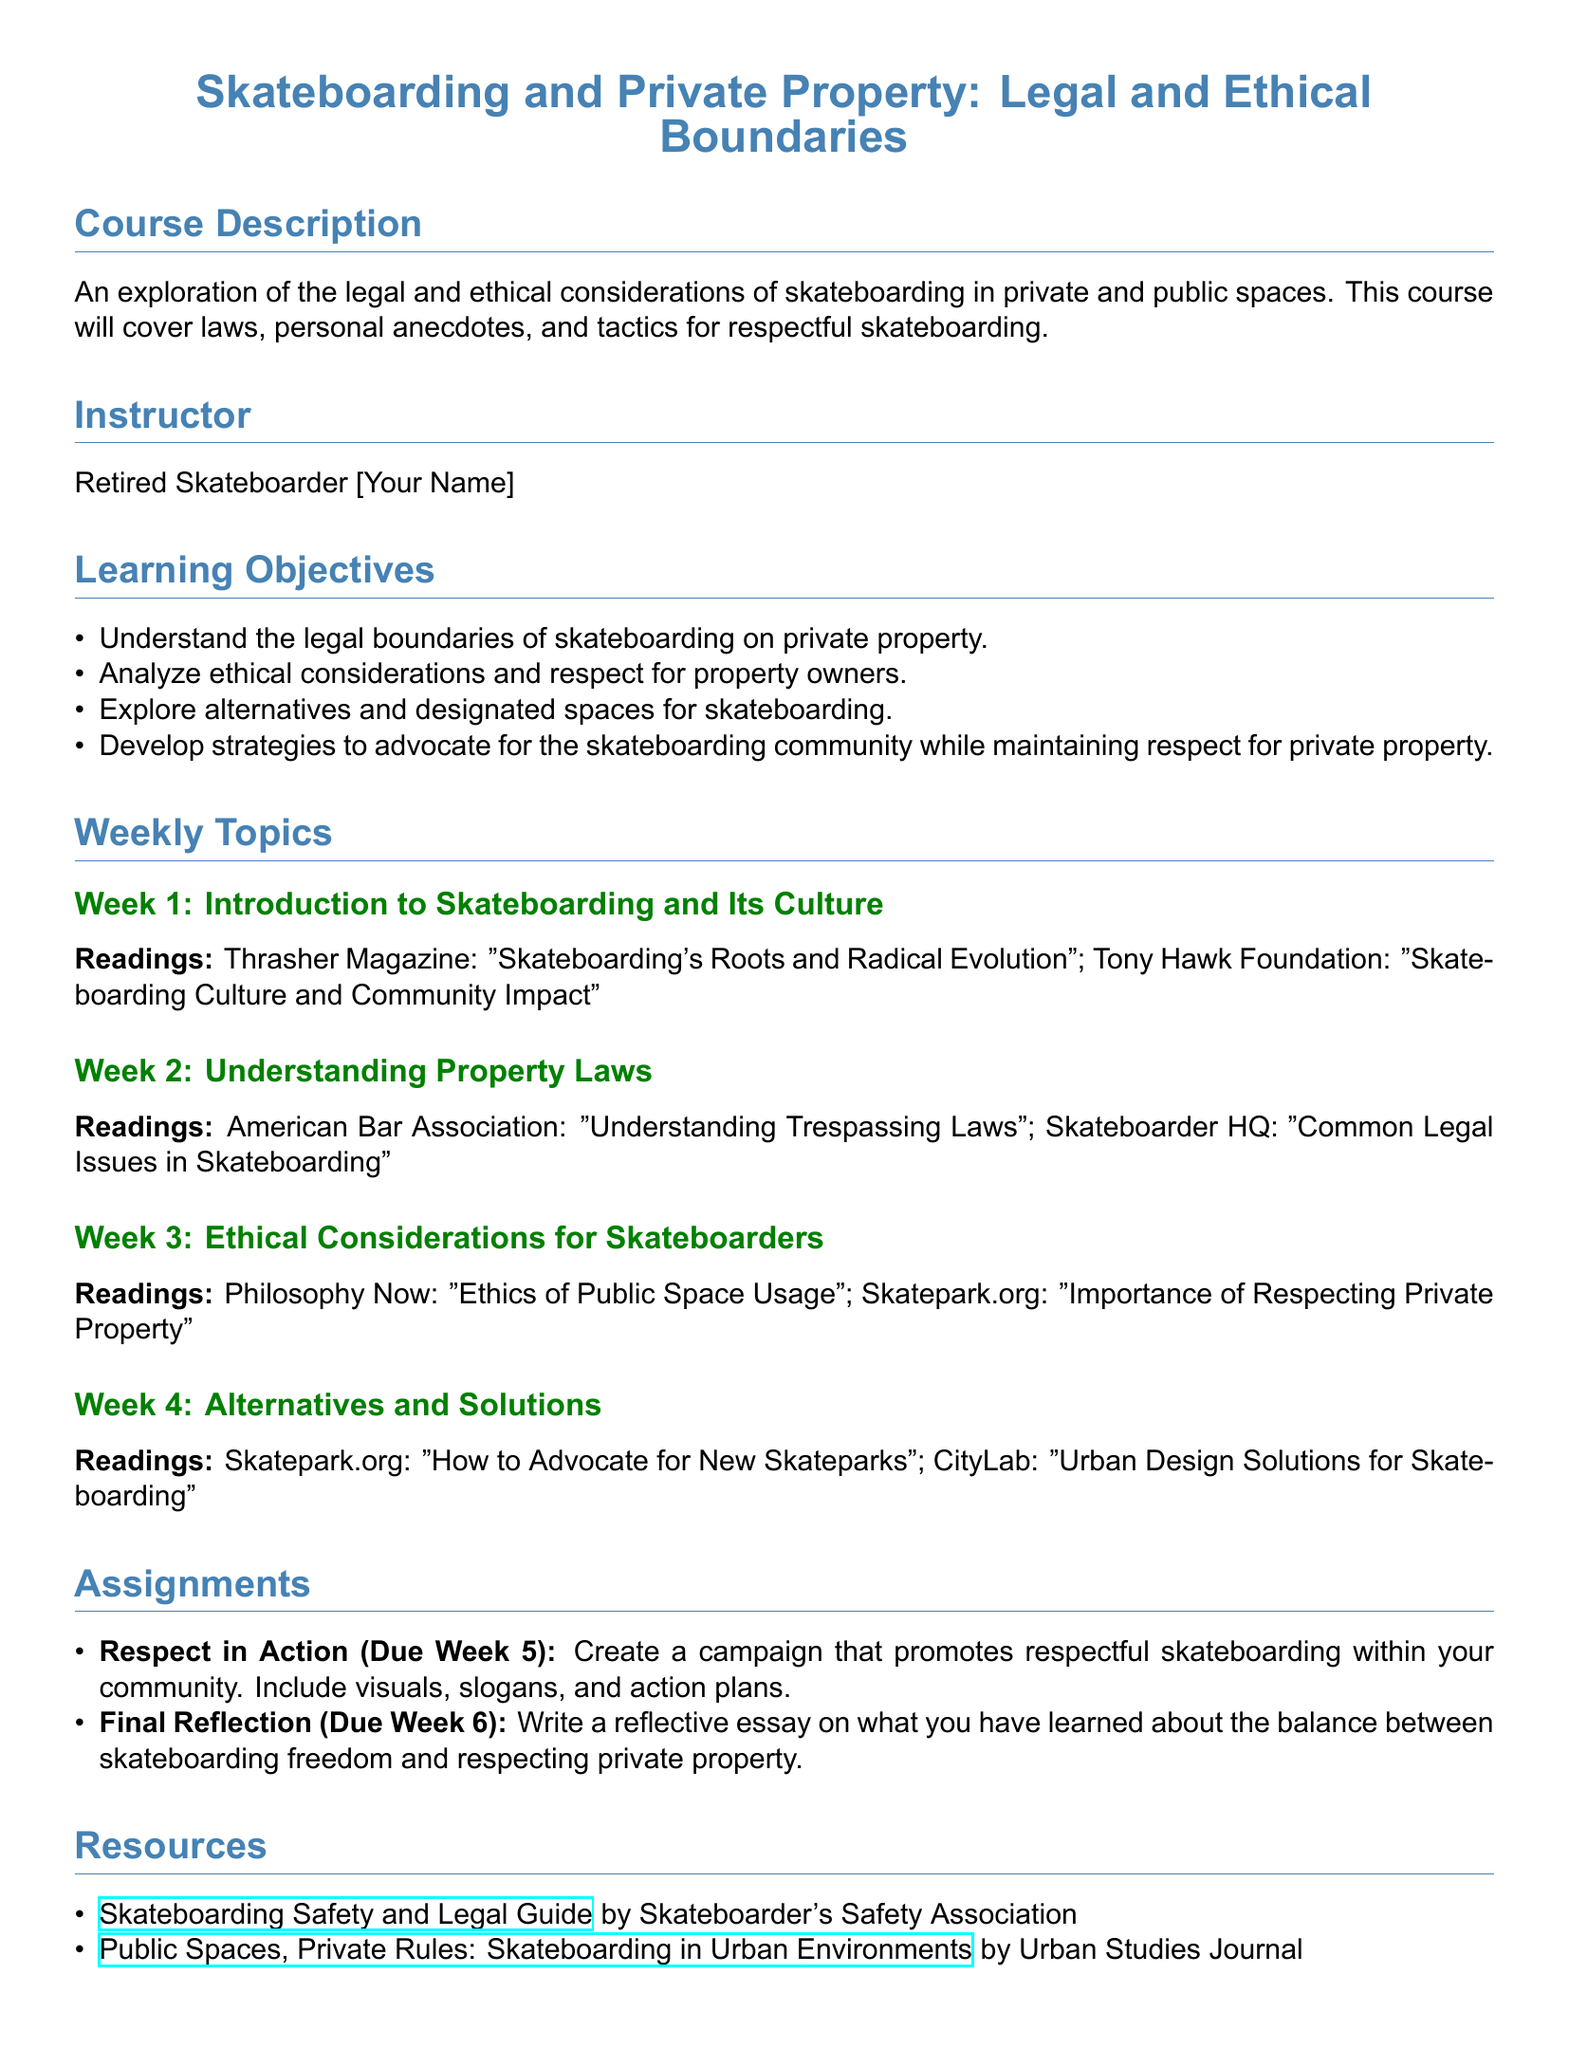What is the course title? The course title is presented at the top of the document and is focused on skateboarding and its relation to private property.
Answer: Skateboarding and Private Property: Legal and Ethical Boundaries Who is the instructor of the course? The instructor's name is included in the syllabus, listed under the instructor section.
Answer: Retired Skateboarder [Your Name] What is due in Week 5? The assignments section states what students must submit and when, highlighting the task due in Week 5.
Answer: Respect in Action How many weekly topics are covered in the syllabus? The number of weekly topics is listed throughout the document, starting from Week 1 to Week 4.
Answer: Four What reading is assigned for Week 3? The readings for each week are specified within the weekly topics section, specifically under Week 3.
Answer: Philosophy Now: "Ethics of Public Space Usage" What type of essay is due in Week 6? The assignment description for Week 6 indicates the nature of the reflective task students need to complete.
Answer: Reflective essay What is one resource listed for skateboarders? The resources section contains links and titles of guides and articles helpful for skateboarders.
Answer: Skateboarding Safety and Legal Guide by Skateboarder's Safety Association What key concept is emphasized in the learning objectives? The learning objectives provide insight into the core themes of the course, specifically about property.
Answer: Respect for property owners 